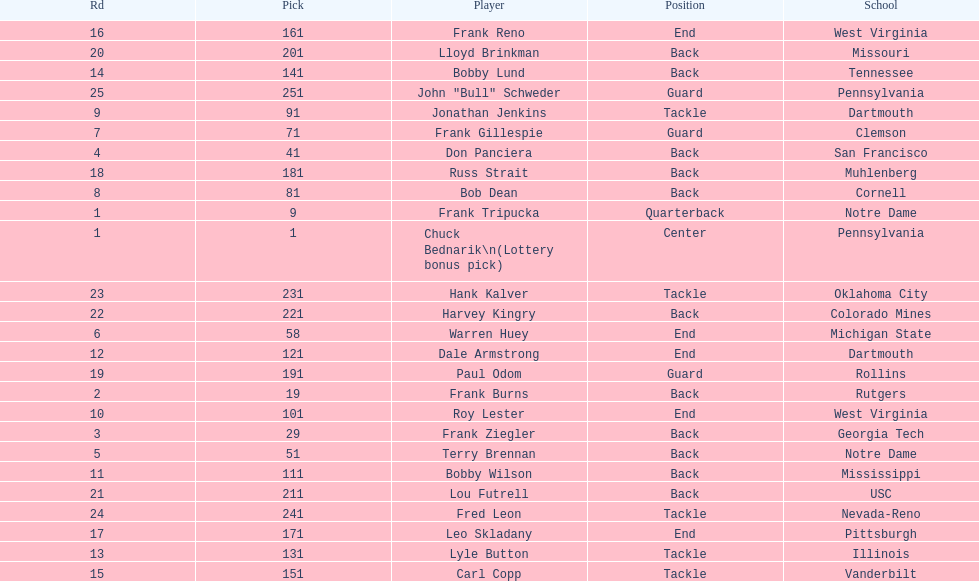How many draft picks were between frank tripucka and dale armstrong? 10. 